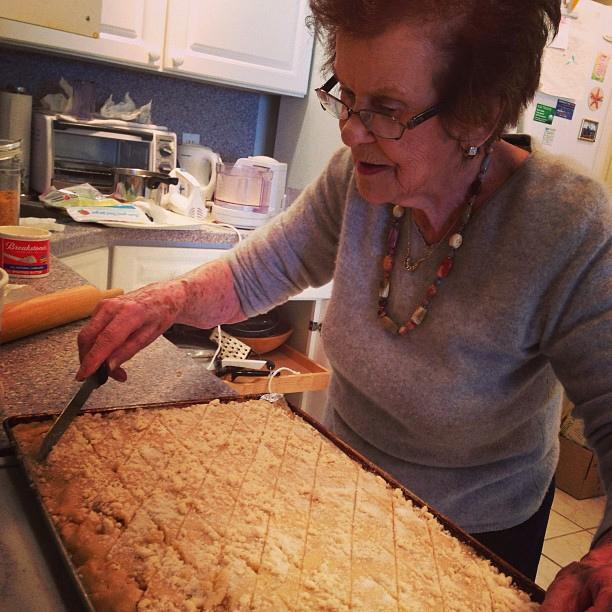What is the woman doing to her cake?

Choices:
A) stirring
B) freezing
C) puncturing
D) cross hatching cross hatching 